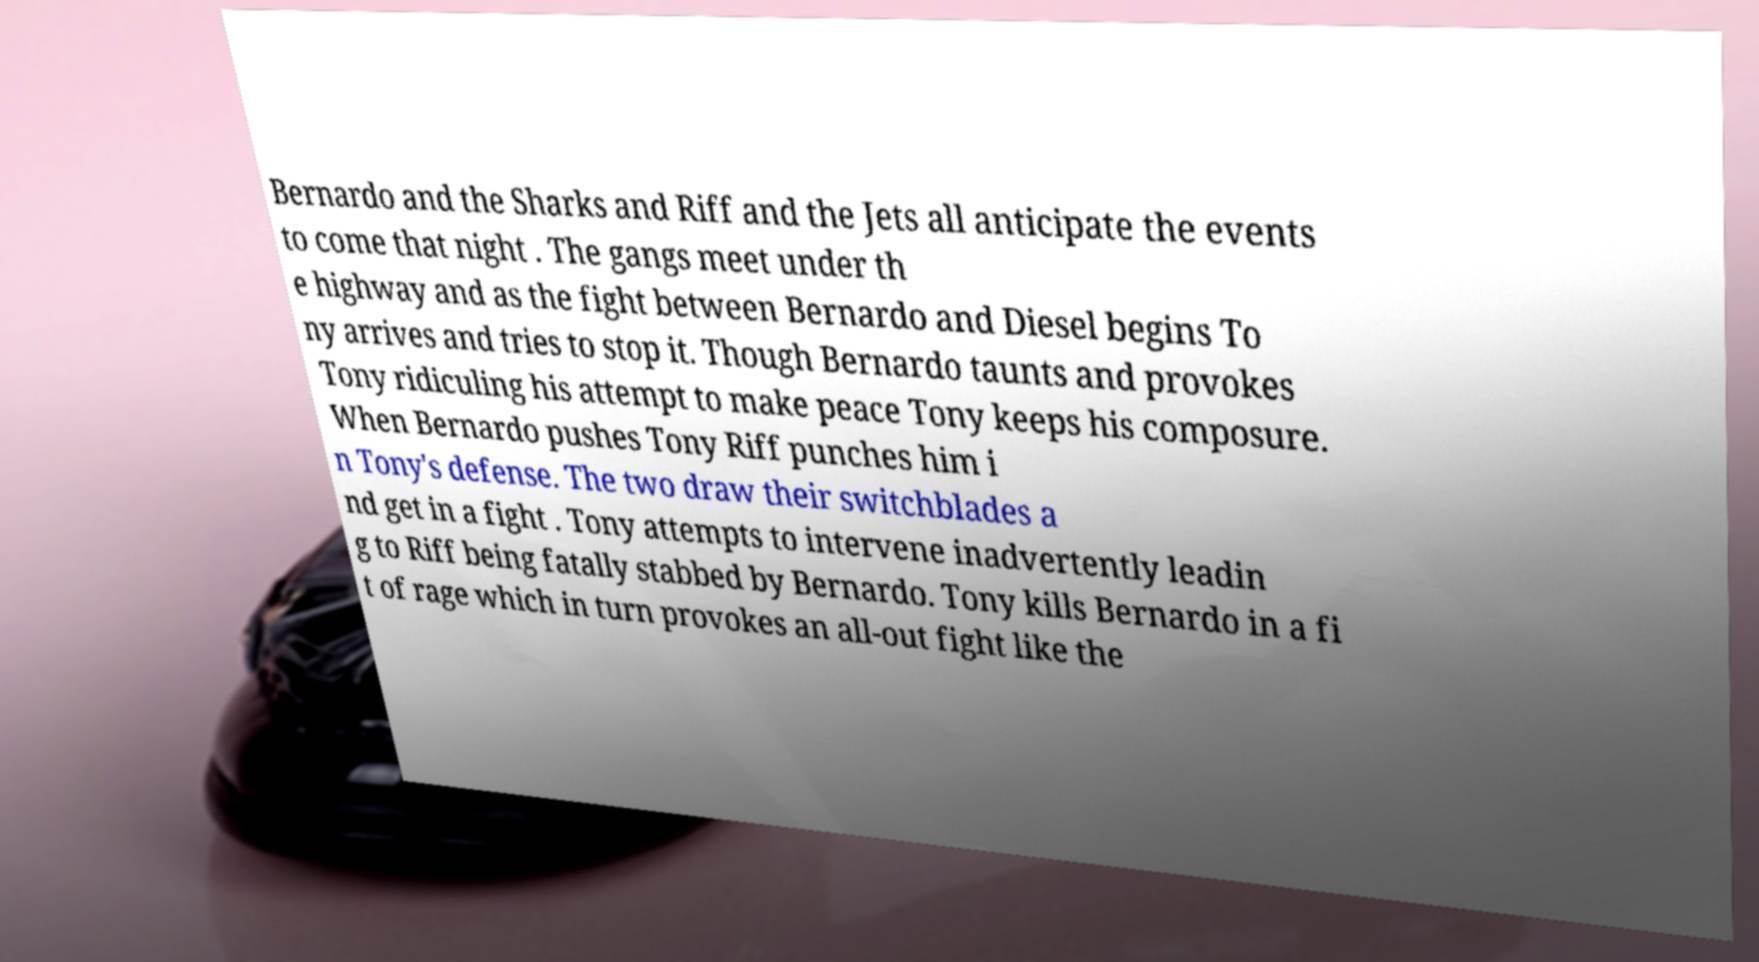I need the written content from this picture converted into text. Can you do that? Bernardo and the Sharks and Riff and the Jets all anticipate the events to come that night . The gangs meet under th e highway and as the fight between Bernardo and Diesel begins To ny arrives and tries to stop it. Though Bernardo taunts and provokes Tony ridiculing his attempt to make peace Tony keeps his composure. When Bernardo pushes Tony Riff punches him i n Tony's defense. The two draw their switchblades a nd get in a fight . Tony attempts to intervene inadvertently leadin g to Riff being fatally stabbed by Bernardo. Tony kills Bernardo in a fi t of rage which in turn provokes an all-out fight like the 